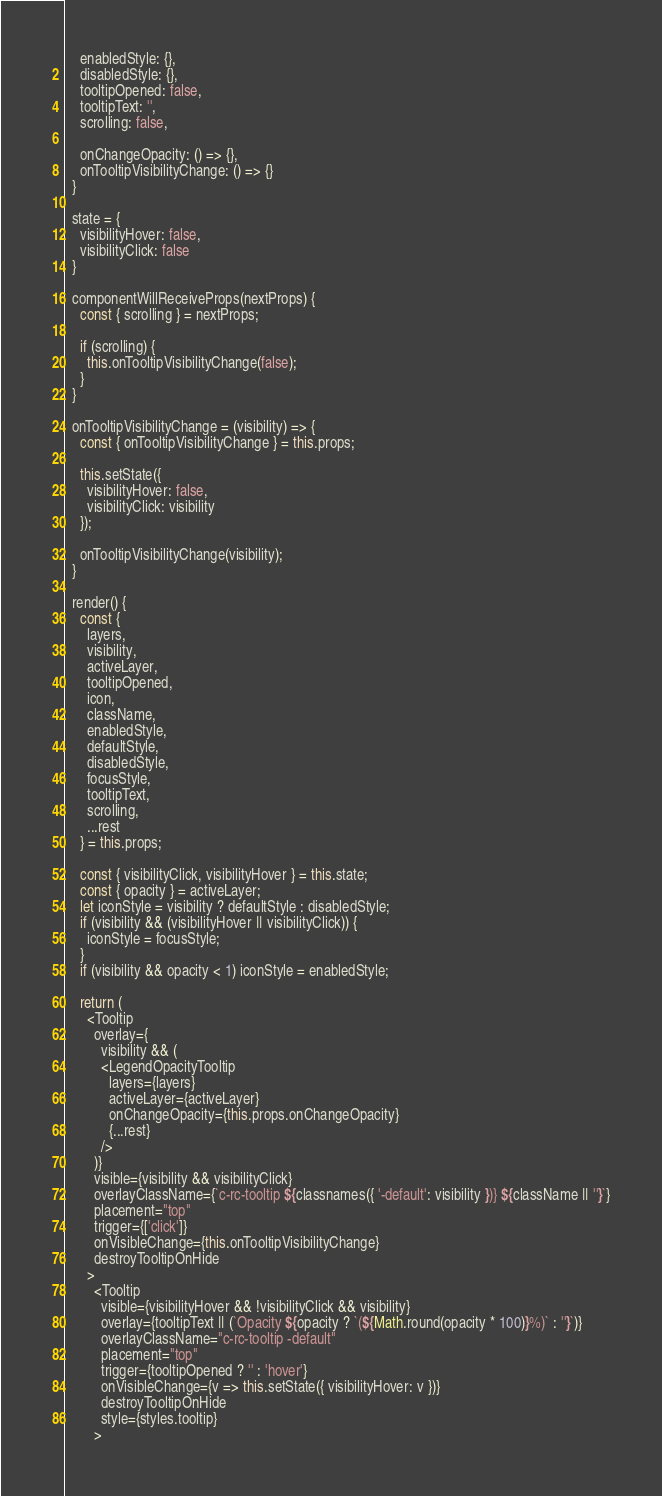<code> <loc_0><loc_0><loc_500><loc_500><_JavaScript_>    enabledStyle: {},
    disabledStyle: {},
    tooltipOpened: false,
    tooltipText: '',
    scrolling: false,

    onChangeOpacity: () => {},
    onTooltipVisibilityChange: () => {}
  }

  state = {
    visibilityHover: false,
    visibilityClick: false
  }

  componentWillReceiveProps(nextProps) {
    const { scrolling } = nextProps;
    
    if (scrolling) {
      this.onTooltipVisibilityChange(false);
    }
  }

  onTooltipVisibilityChange = (visibility) => {
    const { onTooltipVisibilityChange } = this.props;
    
    this.setState({
      visibilityHover: false,
      visibilityClick: visibility
    });

    onTooltipVisibilityChange(visibility);
  }

  render() {
    const {
      layers,
      visibility,
      activeLayer,
      tooltipOpened,
      icon,
      className,
      enabledStyle,
      defaultStyle,
      disabledStyle,
      focusStyle,
      tooltipText,
      scrolling,
      ...rest
    } = this.props;

    const { visibilityClick, visibilityHover } = this.state;
    const { opacity } = activeLayer;
    let iconStyle = visibility ? defaultStyle : disabledStyle;
    if (visibility && (visibilityHover || visibilityClick)) {
      iconStyle = focusStyle;
    }
    if (visibility && opacity < 1) iconStyle = enabledStyle;

    return (
      <Tooltip
        overlay={
          visibility && (
          <LegendOpacityTooltip
            layers={layers}
            activeLayer={activeLayer}
            onChangeOpacity={this.props.onChangeOpacity}
            {...rest}
          />
        )}
        visible={visibility && visibilityClick}
        overlayClassName={`c-rc-tooltip ${classnames({ '-default': visibility })} ${className || ''}`}
        placement="top"
        trigger={['click']}
        onVisibleChange={this.onTooltipVisibilityChange}
        destroyTooltipOnHide
      >
        <Tooltip
          visible={visibilityHover && !visibilityClick && visibility}
          overlay={tooltipText || (`Opacity ${opacity ? `(${Math.round(opacity * 100)}%)` : ''}`)}
          overlayClassName="c-rc-tooltip -default"
          placement="top"
          trigger={tooltipOpened ? '' : 'hover'}
          onVisibleChange={v => this.setState({ visibilityHover: v })}
          destroyTooltipOnHide
          style={styles.tooltip}
        ></code> 